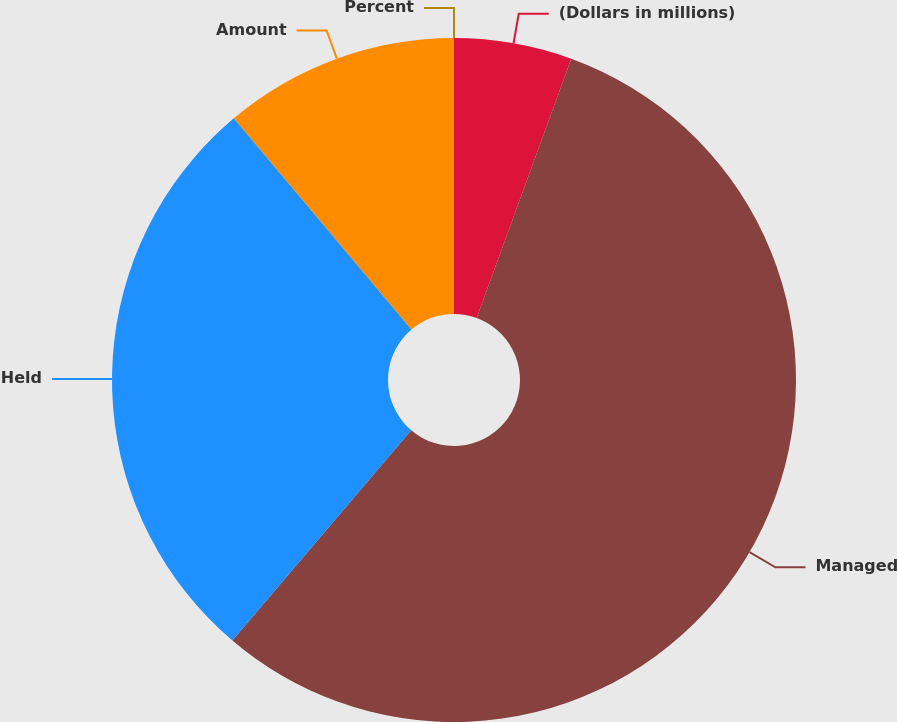Convert chart to OTSL. <chart><loc_0><loc_0><loc_500><loc_500><pie_chart><fcel>(Dollars in millions)<fcel>Managed<fcel>Held<fcel>Amount<fcel>Percent<nl><fcel>5.57%<fcel>55.65%<fcel>27.65%<fcel>11.13%<fcel>0.0%<nl></chart> 